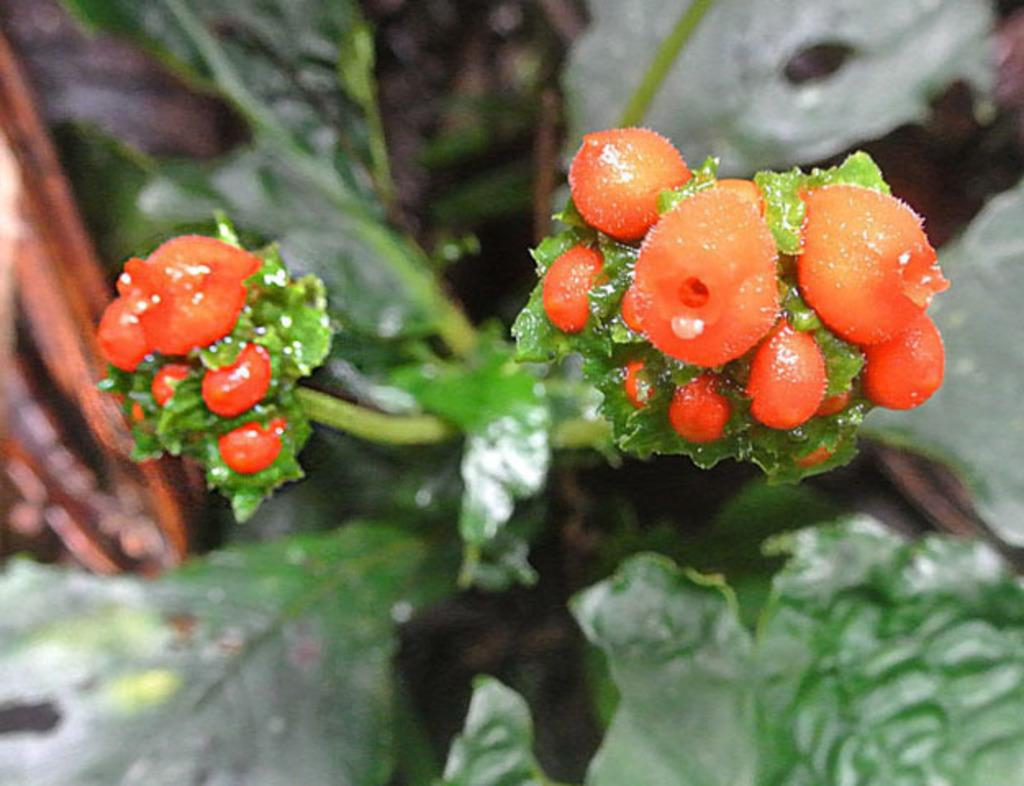What type of food can be seen in the image? There are fruits in the image. What else is present in the image besides the fruits? There are leaves in the image. How would you describe the background of the image? The background of the image is blurred. What type of mist can be seen in the image? There is no mist present in the image. Is there a plane visible in the image? There is no plane present in the image. 